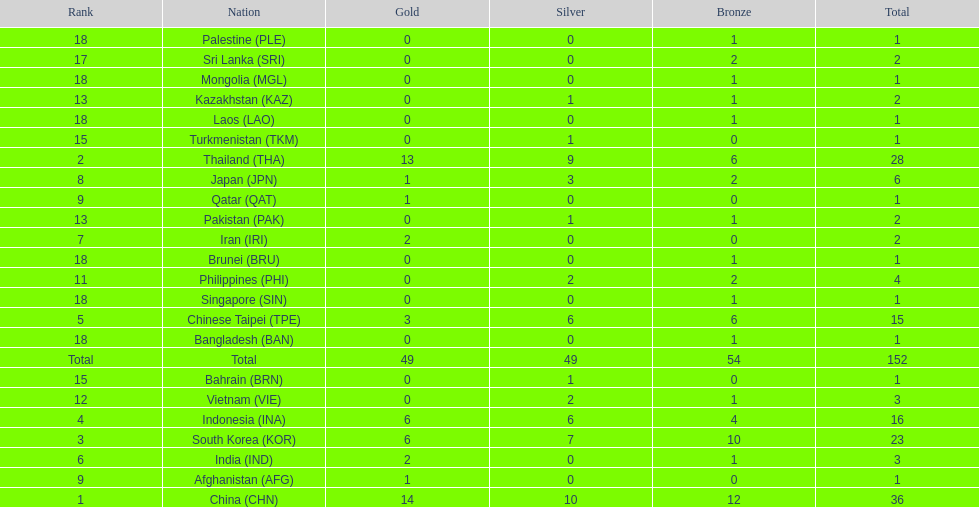How many more medals did india earn compared to pakistan? 1. 